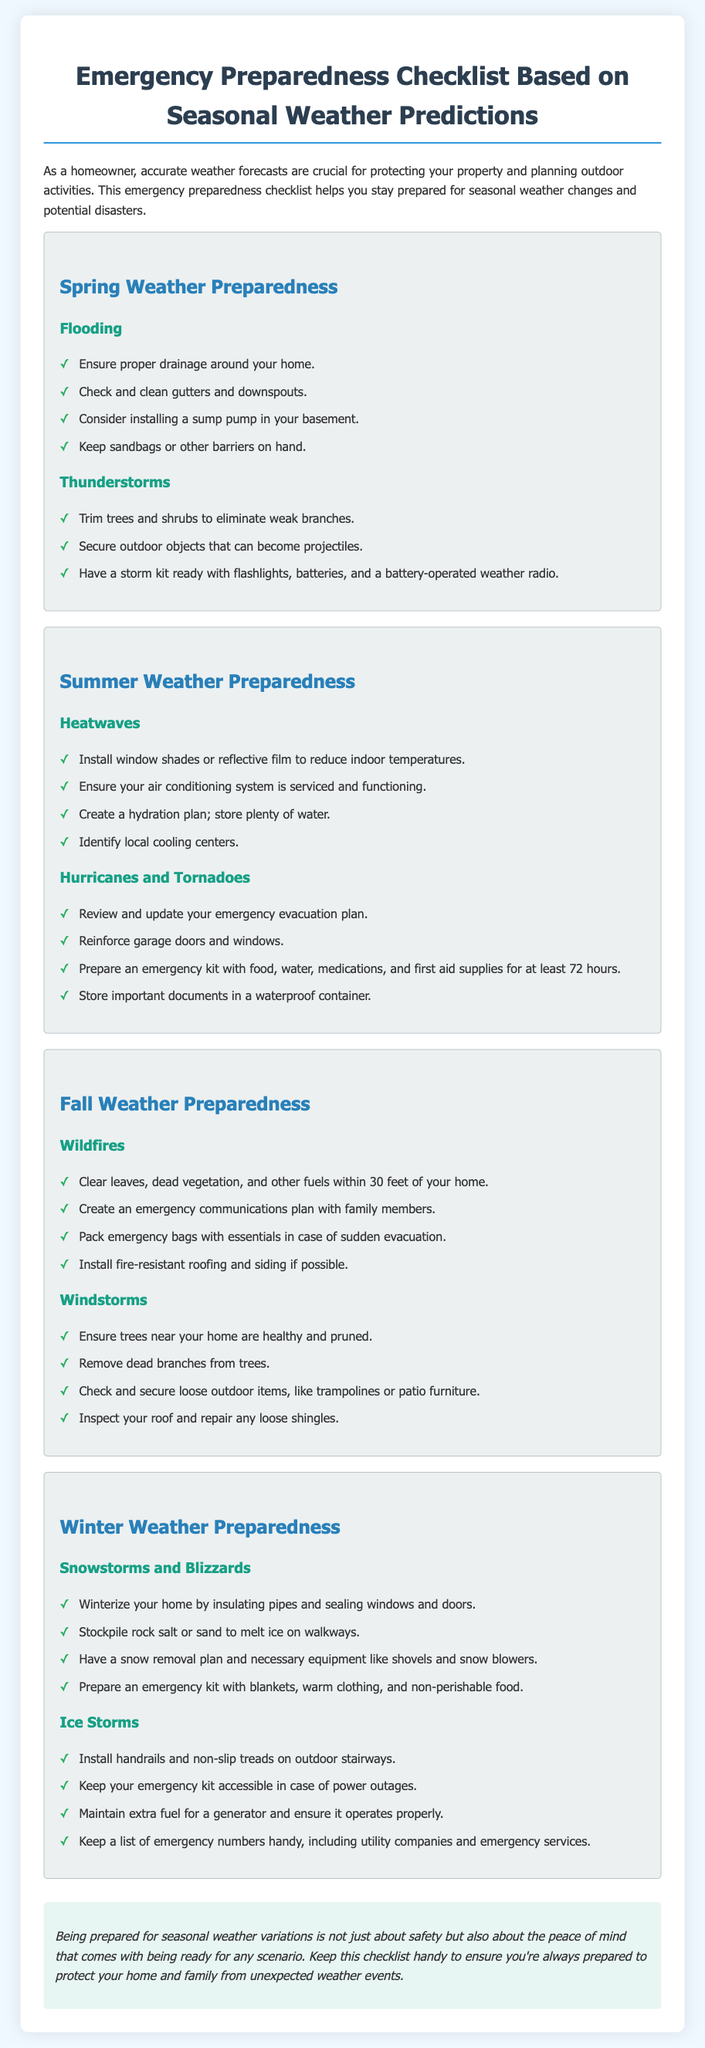What is the title of the document? The title is located at the top of the document, indicating the primary focus on emergency preparedness based on seasonal weather predictions.
Answer: Emergency Preparedness Checklist Based on Seasonal Weather Predictions How many seasonal weather preparedness sections are in the document? The document has distinct sections for each season, specifically outlining preparedness measures for spring, summer, fall, and winter.
Answer: Four What should you keep on hand for flooding? The checklist lists specific items to prepare for flooding under the spring section.
Answer: Sandbags or other barriers What type of storms does the summer section focus on? The document specifies the types of severe weather to prepare for during summer, detailing two major threats.
Answer: Hurricanes and Tornadoes Which season requires winterizing your home? This question pertains to the crucial preparations necessary for protecting one’s home during specific cold-weather situations outlined in the document.
Answer: Winter What should be included in an emergency kit during snowstorms? The document provides a specific example of items to prepare in the emergency kit for snowstorms and blizzards.
Answer: Blankets, warm clothing, and non-perishable food What should you check and clean in spring? This question highlights routine maintenance tasks mentioned to prepare for specific weather challenges in spring.
Answer: Gutters and downspouts What is one measure for preparing against wildfires? This question relates to specific actions homeowners should take to minimize wildfire risks based on the document's guidelines.
Answer: Clear leaves, dead vegetation, and other fuels within 30 feet of your home 